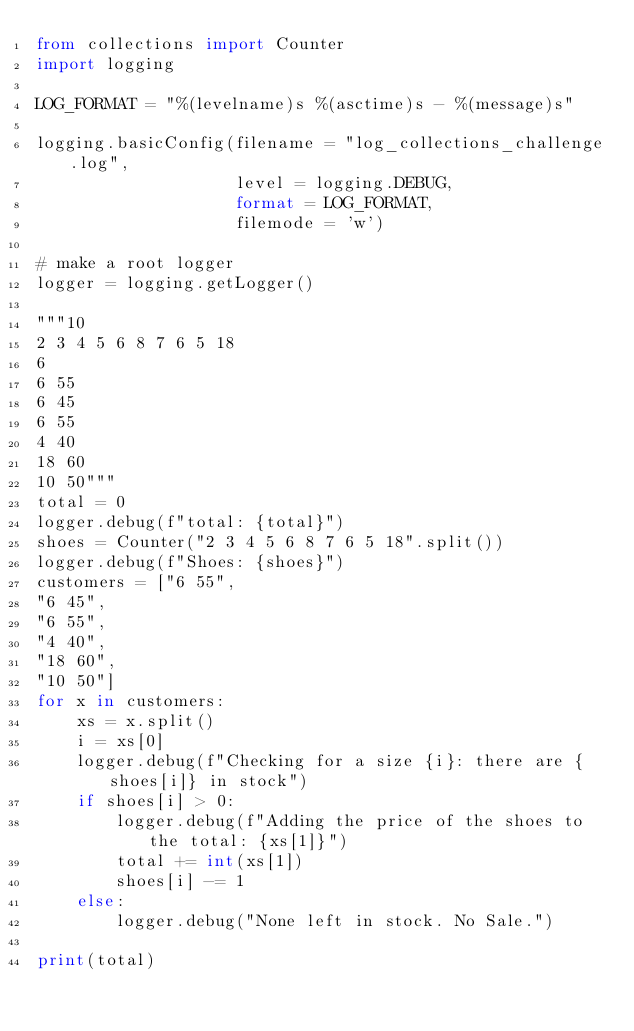Convert code to text. <code><loc_0><loc_0><loc_500><loc_500><_Python_>from collections import Counter
import logging

LOG_FORMAT = "%(levelname)s %(asctime)s - %(message)s"

logging.basicConfig(filename = "log_collections_challenge.log",
                    level = logging.DEBUG,
                    format = LOG_FORMAT,
                    filemode = 'w')

# make a root logger
logger = logging.getLogger()

"""10
2 3 4 5 6 8 7 6 5 18
6
6 55
6 45
6 55
4 40
18 60
10 50"""
total = 0
logger.debug(f"total: {total}")
shoes = Counter("2 3 4 5 6 8 7 6 5 18".split())
logger.debug(f"Shoes: {shoes}")
customers = ["6 55",
"6 45",
"6 55",
"4 40",
"18 60",
"10 50"]
for x in customers:
    xs = x.split()
    i = xs[0]
    logger.debug(f"Checking for a size {i}: there are {shoes[i]} in stock")
    if shoes[i] > 0:
        logger.debug(f"Adding the price of the shoes to the total: {xs[1]}")
        total += int(xs[1])
        shoes[i] -= 1
    else:
        logger.debug("None left in stock. No Sale.")

print(total)
</code> 